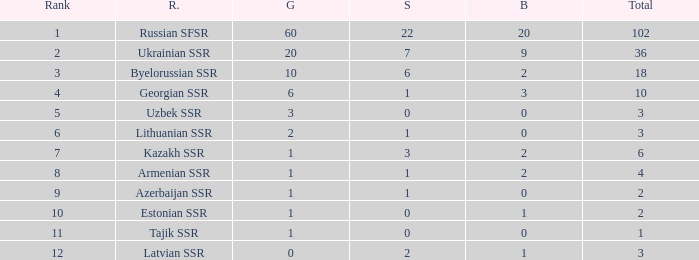What is the highest number of bronzes for teams ranked number 7 with more than 0 silver? 2.0. 